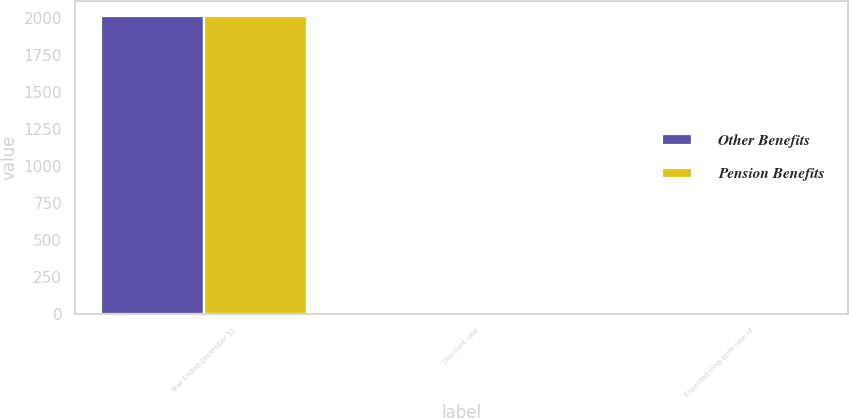<chart> <loc_0><loc_0><loc_500><loc_500><stacked_bar_chart><ecel><fcel>Year Ended December 31<fcel>Discount rate<fcel>Expected long-term rate of<nl><fcel>Other Benefits<fcel>2013<fcel>4<fcel>8.25<nl><fcel>Pension Benefits<fcel>2013<fcel>4<fcel>4.75<nl></chart> 